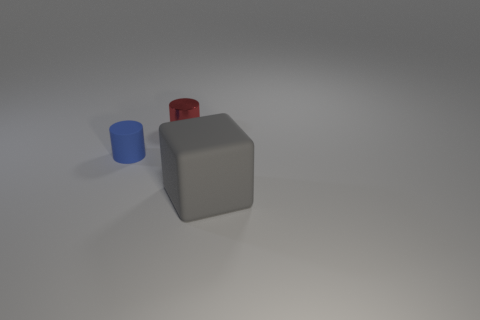Add 2 tiny yellow shiny cylinders. How many objects exist? 5 Subtract all blue cylinders. How many cylinders are left? 1 Subtract 1 cylinders. How many cylinders are left? 1 Subtract all blocks. How many objects are left? 2 Add 2 big purple objects. How many big purple objects exist? 2 Subtract 1 red cylinders. How many objects are left? 2 Subtract all brown cylinders. Subtract all red spheres. How many cylinders are left? 2 Subtract all blue objects. Subtract all large matte blocks. How many objects are left? 1 Add 2 large gray objects. How many large gray objects are left? 3 